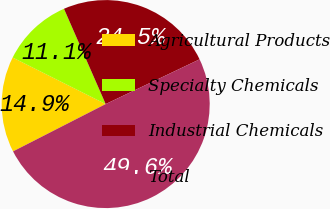Convert chart. <chart><loc_0><loc_0><loc_500><loc_500><pie_chart><fcel>Agricultural Products<fcel>Specialty Chemicals<fcel>Industrial Chemicals<fcel>Total<nl><fcel>14.9%<fcel>11.05%<fcel>24.49%<fcel>49.56%<nl></chart> 